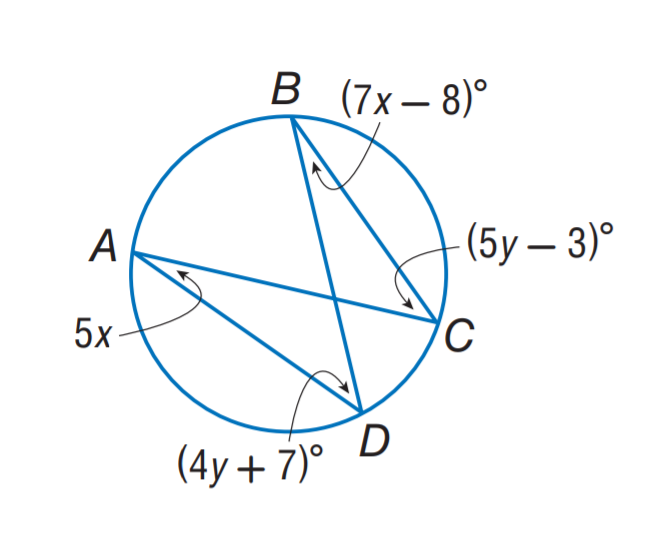Answer the mathemtical geometry problem and directly provide the correct option letter.
Question: Find m \angle C.
Choices: A: 17 B: 20 C: 33 D: 47 D 